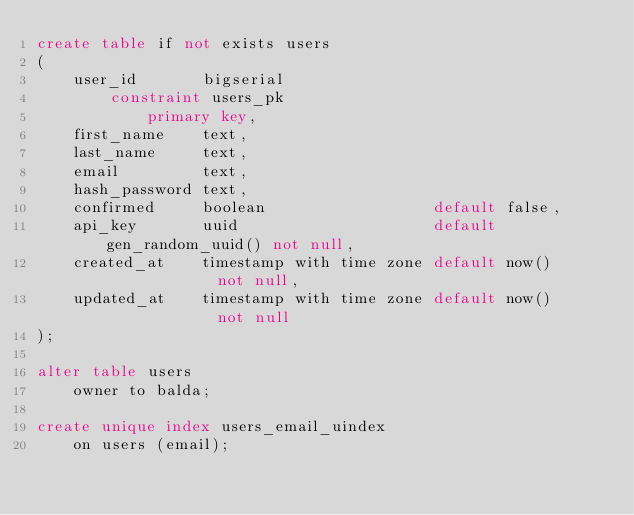<code> <loc_0><loc_0><loc_500><loc_500><_SQL_>create table if not exists users
(
    user_id       bigserial
        constraint users_pk
            primary key,
    first_name    text,
    last_name     text,
    email         text,
    hash_password text,
    confirmed     boolean                  default false,
    api_key       uuid                     default gen_random_uuid() not null,
    created_at    timestamp with time zone default now()             not null,
    updated_at    timestamp with time zone default now()             not null
);

alter table users
    owner to balda;

create unique index users_email_uindex
    on users (email);

</code> 